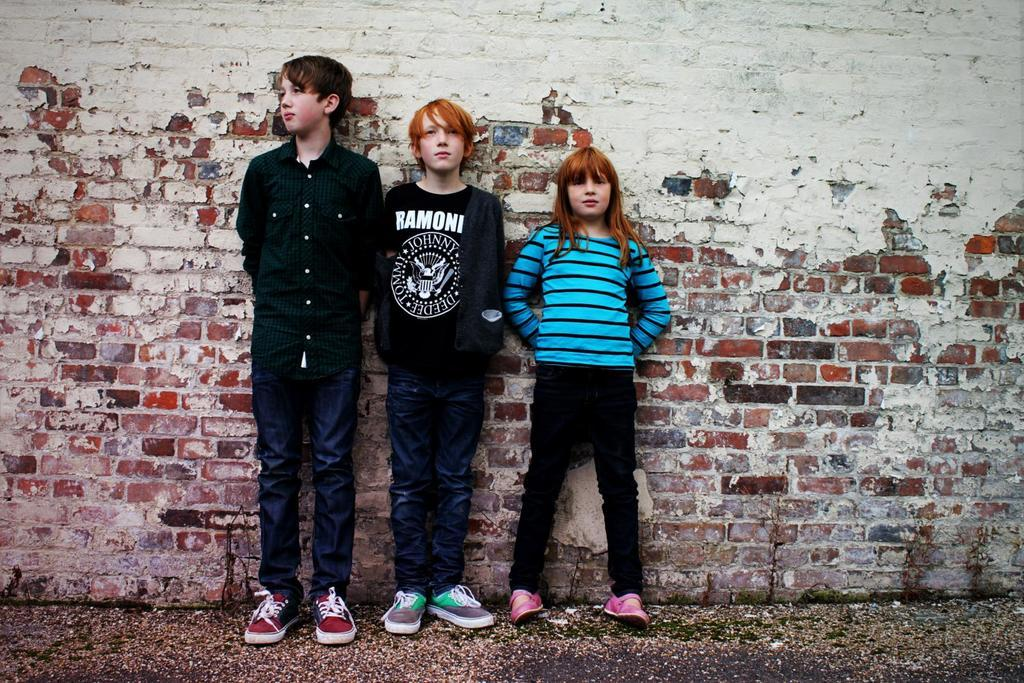How many children are present in the image? There are three children in the image: two boys and a girl. What are the children wearing on their feet? The children are wearing shoes. Where are the children standing? The children are standing on the ground. What can be seen in the background of the image? There is a brick wall in the background of the image. What type of drum is the girl playing in the image? There is no drum present in the image; the girl is not playing any musical instrument. 